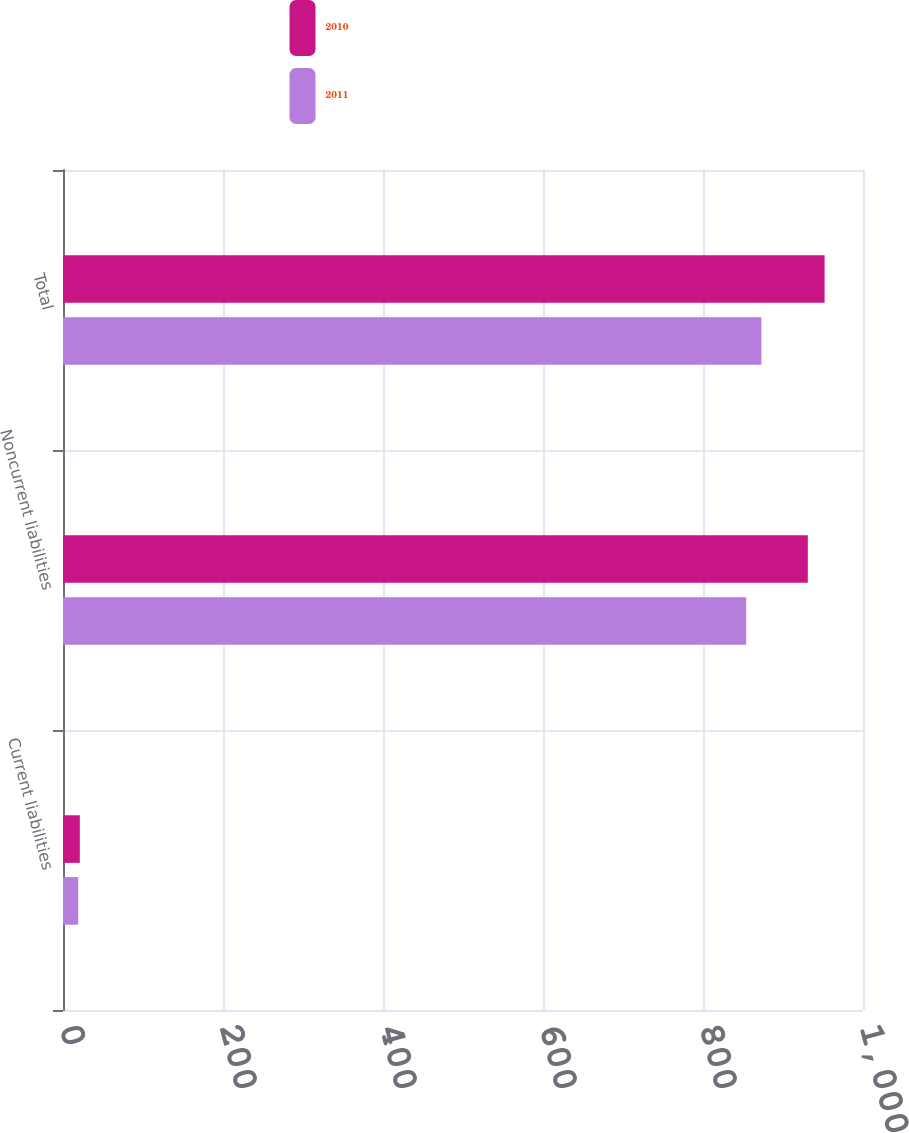Convert chart to OTSL. <chart><loc_0><loc_0><loc_500><loc_500><stacked_bar_chart><ecel><fcel>Current liabilities<fcel>Noncurrent liabilities<fcel>Total<nl><fcel>2010<fcel>21<fcel>931<fcel>952<nl><fcel>2011<fcel>19<fcel>854<fcel>873<nl></chart> 